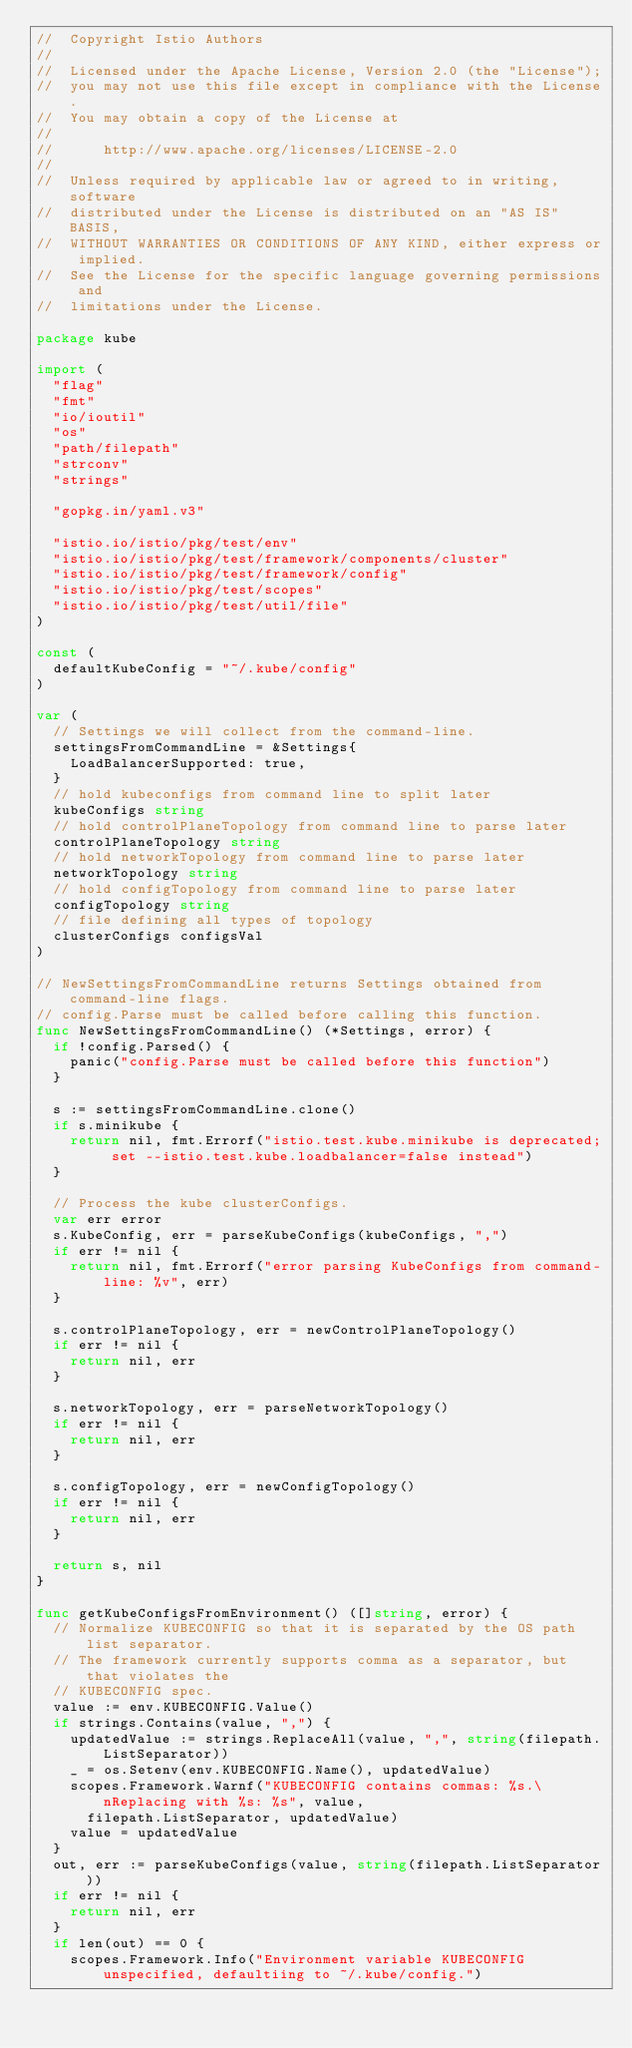<code> <loc_0><loc_0><loc_500><loc_500><_Go_>//  Copyright Istio Authors
//
//  Licensed under the Apache License, Version 2.0 (the "License");
//  you may not use this file except in compliance with the License.
//  You may obtain a copy of the License at
//
//      http://www.apache.org/licenses/LICENSE-2.0
//
//  Unless required by applicable law or agreed to in writing, software
//  distributed under the License is distributed on an "AS IS" BASIS,
//  WITHOUT WARRANTIES OR CONDITIONS OF ANY KIND, either express or implied.
//  See the License for the specific language governing permissions and
//  limitations under the License.

package kube

import (
	"flag"
	"fmt"
	"io/ioutil"
	"os"
	"path/filepath"
	"strconv"
	"strings"

	"gopkg.in/yaml.v3"

	"istio.io/istio/pkg/test/env"
	"istio.io/istio/pkg/test/framework/components/cluster"
	"istio.io/istio/pkg/test/framework/config"
	"istio.io/istio/pkg/test/scopes"
	"istio.io/istio/pkg/test/util/file"
)

const (
	defaultKubeConfig = "~/.kube/config"
)

var (
	// Settings we will collect from the command-line.
	settingsFromCommandLine = &Settings{
		LoadBalancerSupported: true,
	}
	// hold kubeconfigs from command line to split later
	kubeConfigs string
	// hold controlPlaneTopology from command line to parse later
	controlPlaneTopology string
	// hold networkTopology from command line to parse later
	networkTopology string
	// hold configTopology from command line to parse later
	configTopology string
	// file defining all types of topology
	clusterConfigs configsVal
)

// NewSettingsFromCommandLine returns Settings obtained from command-line flags.
// config.Parse must be called before calling this function.
func NewSettingsFromCommandLine() (*Settings, error) {
	if !config.Parsed() {
		panic("config.Parse must be called before this function")
	}

	s := settingsFromCommandLine.clone()
	if s.minikube {
		return nil, fmt.Errorf("istio.test.kube.minikube is deprecated; set --istio.test.kube.loadbalancer=false instead")
	}

	// Process the kube clusterConfigs.
	var err error
	s.KubeConfig, err = parseKubeConfigs(kubeConfigs, ",")
	if err != nil {
		return nil, fmt.Errorf("error parsing KubeConfigs from command-line: %v", err)
	}

	s.controlPlaneTopology, err = newControlPlaneTopology()
	if err != nil {
		return nil, err
	}

	s.networkTopology, err = parseNetworkTopology()
	if err != nil {
		return nil, err
	}

	s.configTopology, err = newConfigTopology()
	if err != nil {
		return nil, err
	}

	return s, nil
}

func getKubeConfigsFromEnvironment() ([]string, error) {
	// Normalize KUBECONFIG so that it is separated by the OS path list separator.
	// The framework currently supports comma as a separator, but that violates the
	// KUBECONFIG spec.
	value := env.KUBECONFIG.Value()
	if strings.Contains(value, ",") {
		updatedValue := strings.ReplaceAll(value, ",", string(filepath.ListSeparator))
		_ = os.Setenv(env.KUBECONFIG.Name(), updatedValue)
		scopes.Framework.Warnf("KUBECONFIG contains commas: %s.\nReplacing with %s: %s", value,
			filepath.ListSeparator, updatedValue)
		value = updatedValue
	}
	out, err := parseKubeConfigs(value, string(filepath.ListSeparator))
	if err != nil {
		return nil, err
	}
	if len(out) == 0 {
		scopes.Framework.Info("Environment variable KUBECONFIG unspecified, defaultiing to ~/.kube/config.")</code> 